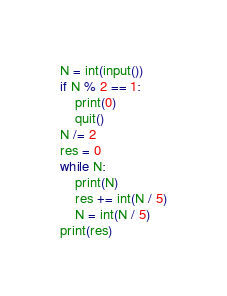<code> <loc_0><loc_0><loc_500><loc_500><_Python_>N = int(input())
if N % 2 == 1:
    print(0)
    quit()
N /= 2
res = 0
while N:
    print(N)
    res += int(N / 5)
    N = int(N / 5)
print(res)</code> 